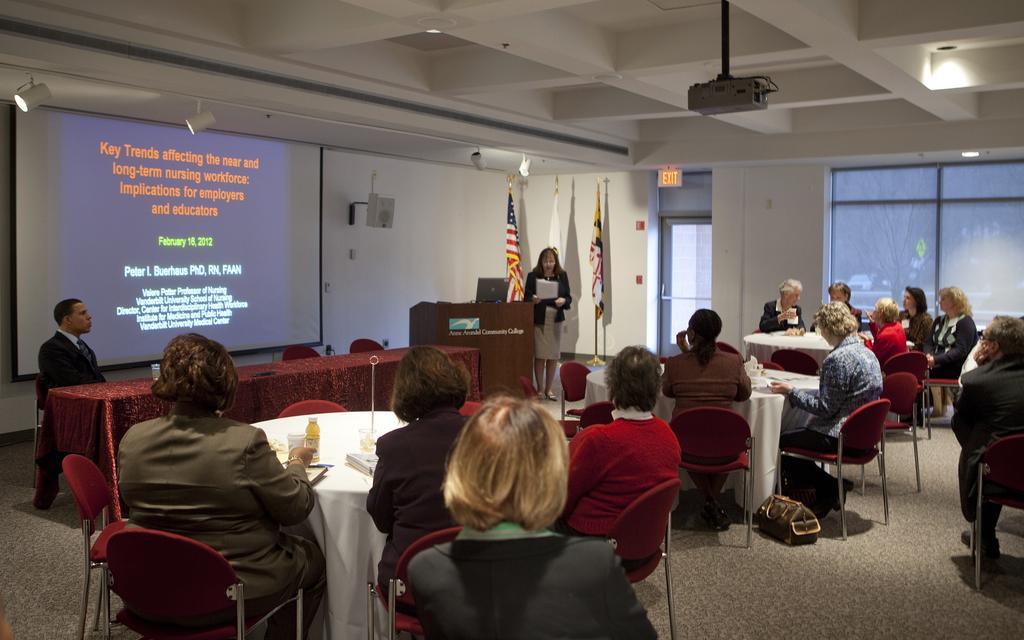Could you give a brief overview of what you see in this image? This image is clicked in a meeting room. There are many persons in this image. The tables are covered with white cloth. To the left, the man sitting is wearing a black suit. To the left, there is a wall on which a screen is fixed. In the background, there are flags and windows. At the top, there is a roof to which a projector and lights are hanged. 